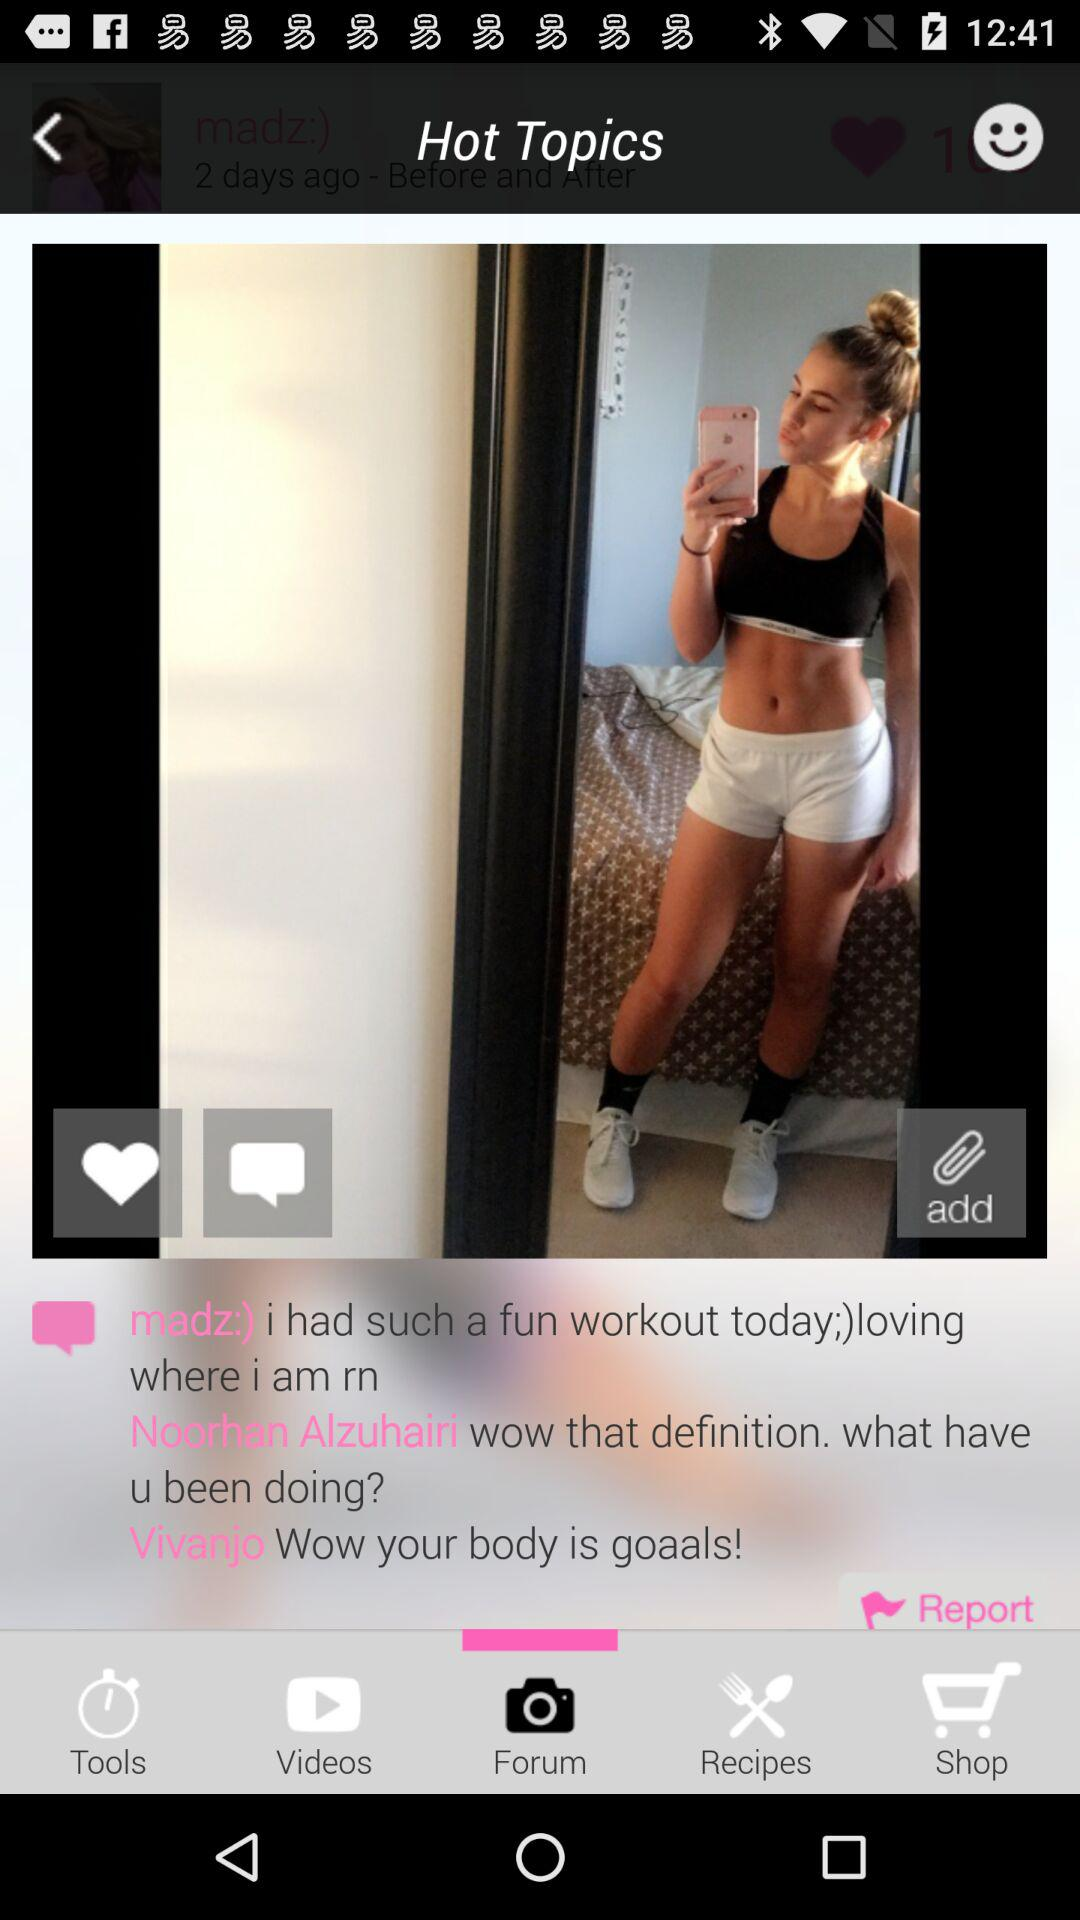Which tab is selected? The selected tab is "Forum". 